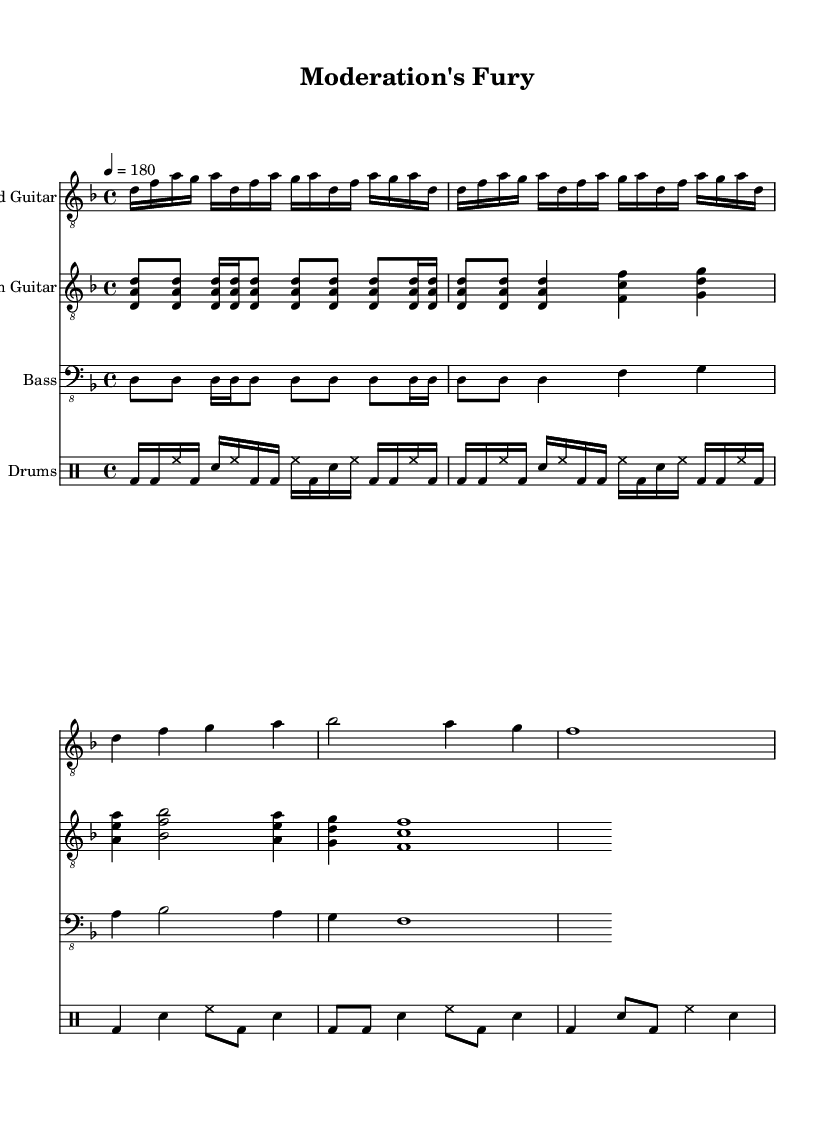What is the key signature of this music? The key signature for this piece is D minor, indicated by the presence of one flat (B flat). You can identify the key signature by looking at the beginning of the staff where the sharps or flats are placed.
Answer: D minor What is the time signature of this music? The time signature is 4/4, which is shown at the beginning of the piece. This means there are four beats in each measure and the quarter note gets one beat.
Answer: 4/4 What is the tempo marking for this piece? The tempo is marked as 4 = 180, which means the quarter note should be played at a rate of 180 beats per minute. Tempos are usually indicated at the start of the score and provide information about the speed of the music.
Answer: 180 How many measures are there in the lead guitar part? There are 4 measures in the lead guitar part, as indicated by the structure of the repeated music sections and the layout of the sheet music. You count measures by identifying the divisions created by vertical lines in the staff.
Answer: 4 What is the instrument name for the second staff? The instrument name for the second staff is "Rhythm Guitar," which is shown at the beginning of that particular staff. Instrument names are usually written at the start of each staff to indicate what instrument is playing.
Answer: Rhythm Guitar What type of rhythm is primarily used in the drum part? The drum part primarily uses a combination of bass drum and snare hits, which create a fast-paced aggressive rhythm typical of death metal. You can analyze this by looking at the rhythm notations within the drum staff.
Answer: Aggressive What is the highest note played by the lead guitar? The highest note played by the lead guitar is A, which is a significant note in the melody and can be identified by looking at the pitches written in the treble clef staff.
Answer: A 